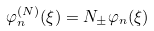<formula> <loc_0><loc_0><loc_500><loc_500>\varphi _ { n } ^ { \left ( N \right ) } ( \xi ) = N _ { \pm } \varphi _ { n } ( \xi )</formula> 